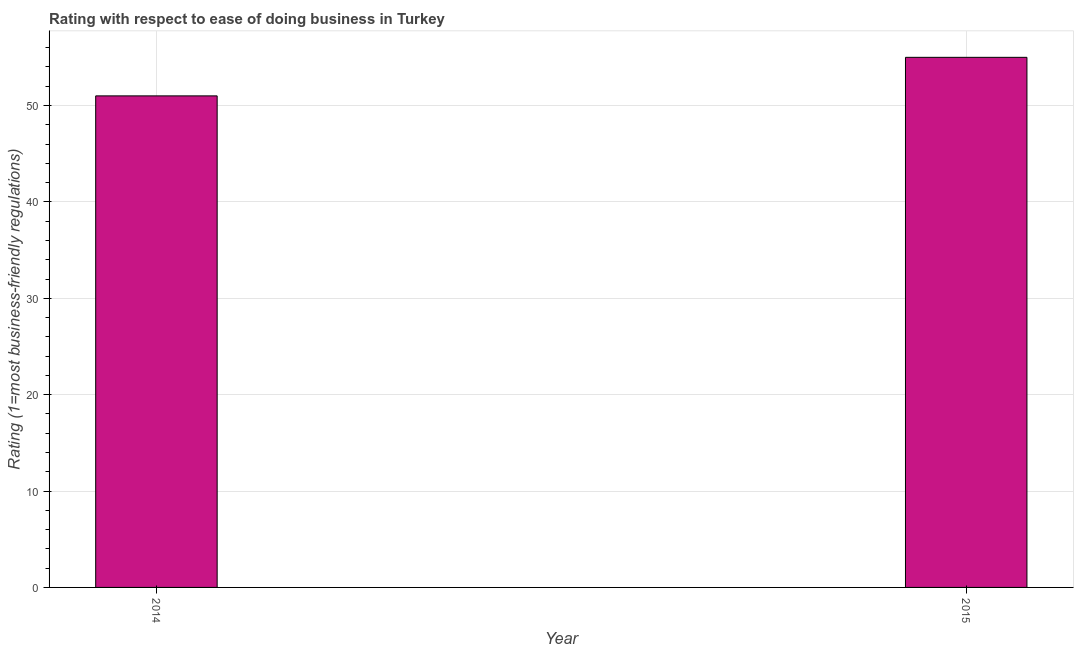Does the graph contain any zero values?
Offer a terse response. No. What is the title of the graph?
Provide a succinct answer. Rating with respect to ease of doing business in Turkey. What is the label or title of the X-axis?
Provide a succinct answer. Year. What is the label or title of the Y-axis?
Give a very brief answer. Rating (1=most business-friendly regulations). Across all years, what is the maximum ease of doing business index?
Your answer should be compact. 55. In which year was the ease of doing business index maximum?
Your answer should be very brief. 2015. What is the sum of the ease of doing business index?
Your response must be concise. 106. What is the difference between the ease of doing business index in 2014 and 2015?
Offer a terse response. -4. Do a majority of the years between 2015 and 2014 (inclusive) have ease of doing business index greater than 12 ?
Provide a short and direct response. No. What is the ratio of the ease of doing business index in 2014 to that in 2015?
Your answer should be very brief. 0.93. Is the ease of doing business index in 2014 less than that in 2015?
Provide a succinct answer. Yes. How many bars are there?
Your answer should be compact. 2. Are all the bars in the graph horizontal?
Your answer should be compact. No. What is the difference between two consecutive major ticks on the Y-axis?
Your response must be concise. 10. What is the ratio of the Rating (1=most business-friendly regulations) in 2014 to that in 2015?
Offer a very short reply. 0.93. 